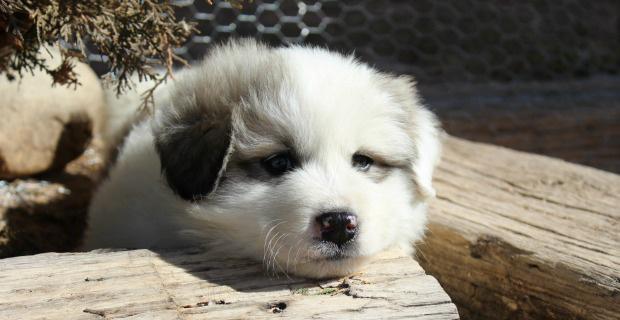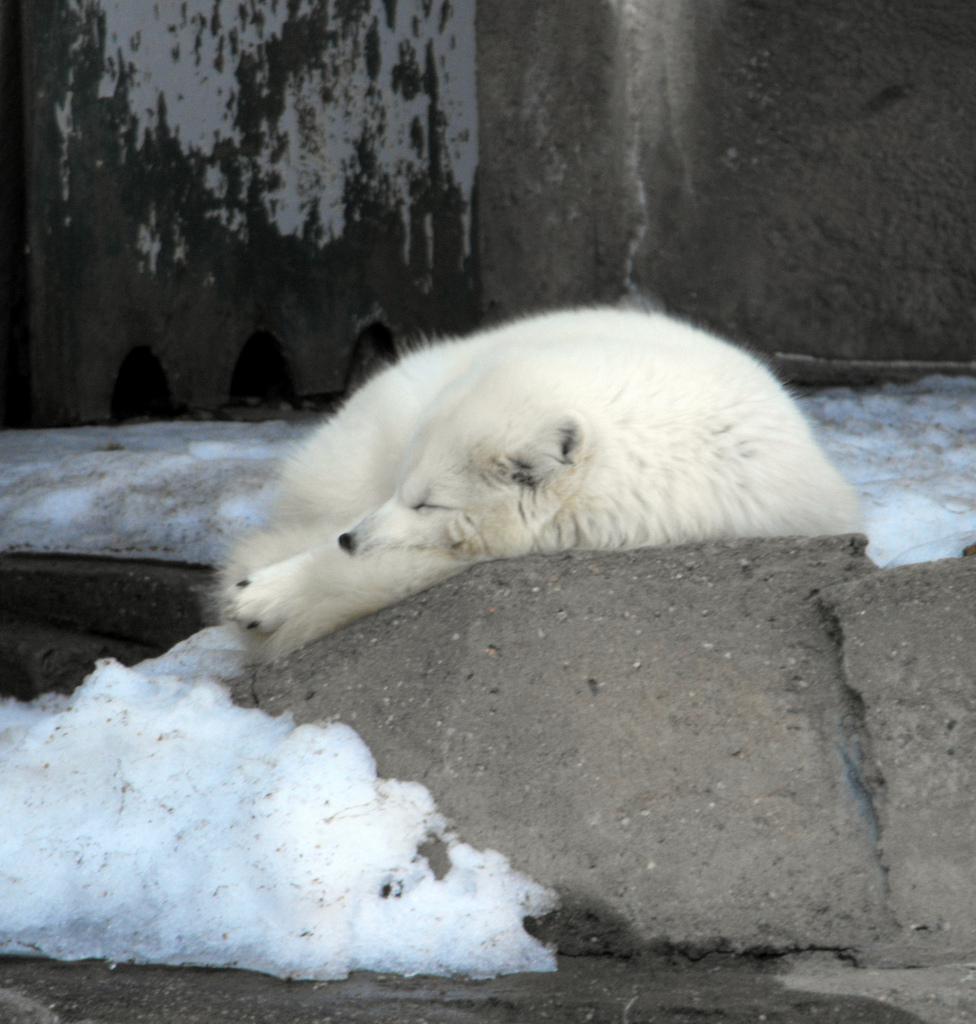The first image is the image on the left, the second image is the image on the right. Assess this claim about the two images: "A white animal is sleeping by water in one of its states of matter.". Correct or not? Answer yes or no. Yes. The first image is the image on the left, the second image is the image on the right. Given the left and right images, does the statement "The dog int he image on the right is standing in a grassy area." hold true? Answer yes or no. No. 